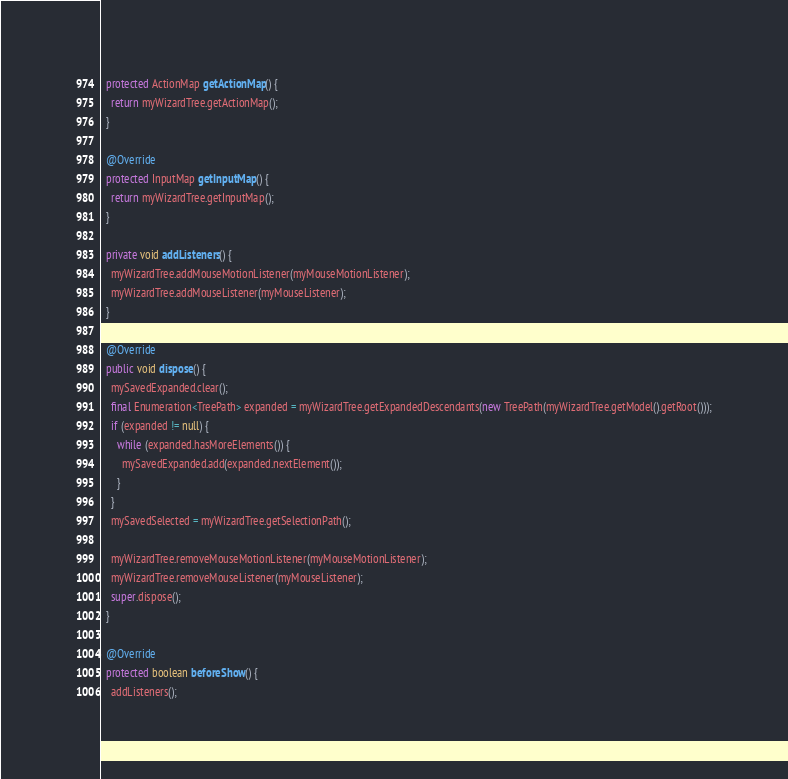<code> <loc_0><loc_0><loc_500><loc_500><_Java_>  protected ActionMap getActionMap() {
    return myWizardTree.getActionMap();
  }

  @Override
  protected InputMap getInputMap() {
    return myWizardTree.getInputMap();
  }

  private void addListeners() {
    myWizardTree.addMouseMotionListener(myMouseMotionListener);
    myWizardTree.addMouseListener(myMouseListener);
  }

  @Override
  public void dispose() {
    mySavedExpanded.clear();
    final Enumeration<TreePath> expanded = myWizardTree.getExpandedDescendants(new TreePath(myWizardTree.getModel().getRoot()));
    if (expanded != null) {
      while (expanded.hasMoreElements()) {
        mySavedExpanded.add(expanded.nextElement());
      }
    }
    mySavedSelected = myWizardTree.getSelectionPath();

    myWizardTree.removeMouseMotionListener(myMouseMotionListener);
    myWizardTree.removeMouseListener(myMouseListener);
    super.dispose();
  }

  @Override
  protected boolean beforeShow() {
    addListeners();
</code> 